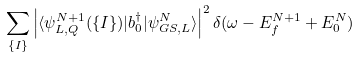<formula> <loc_0><loc_0><loc_500><loc_500>\sum _ { \{ I \} } \left | \langle \psi ^ { N + 1 } _ { L , Q } ( \{ I \} ) | b ^ { \dagger } _ { 0 } | \psi ^ { N } _ { G S , L } \rangle \right | ^ { 2 } \delta ( \omega - E ^ { N + 1 } _ { f } + E ^ { N } _ { 0 } )</formula> 